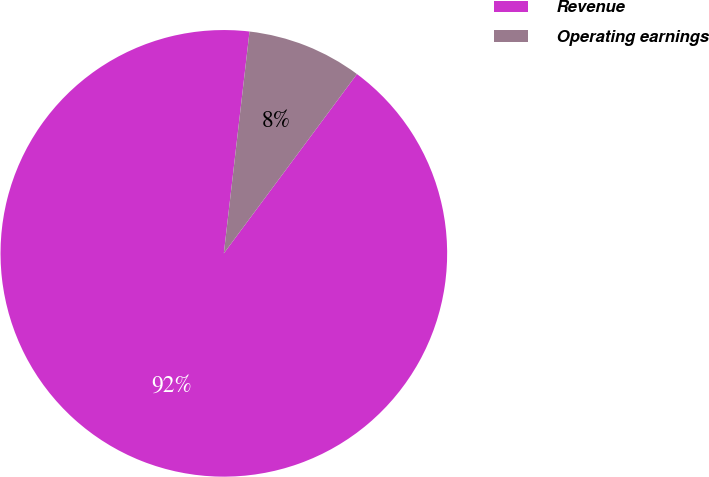Convert chart to OTSL. <chart><loc_0><loc_0><loc_500><loc_500><pie_chart><fcel>Revenue<fcel>Operating earnings<nl><fcel>91.67%<fcel>8.33%<nl></chart> 